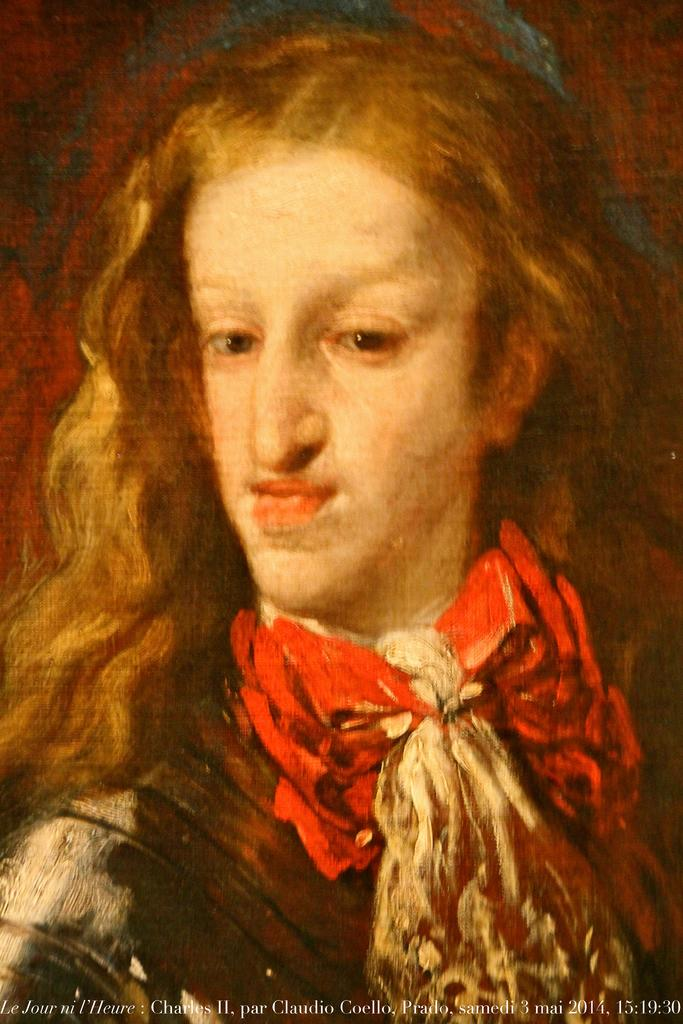What is depicted in the image? There is a painting of a person in the image. Can you describe any additional elements in the image? There is text at the bottom of the image. What type of lead is being used by the person in the painting? There is no lead present in the image, as it is a painting of a person and not a photograph or real-life scene. 